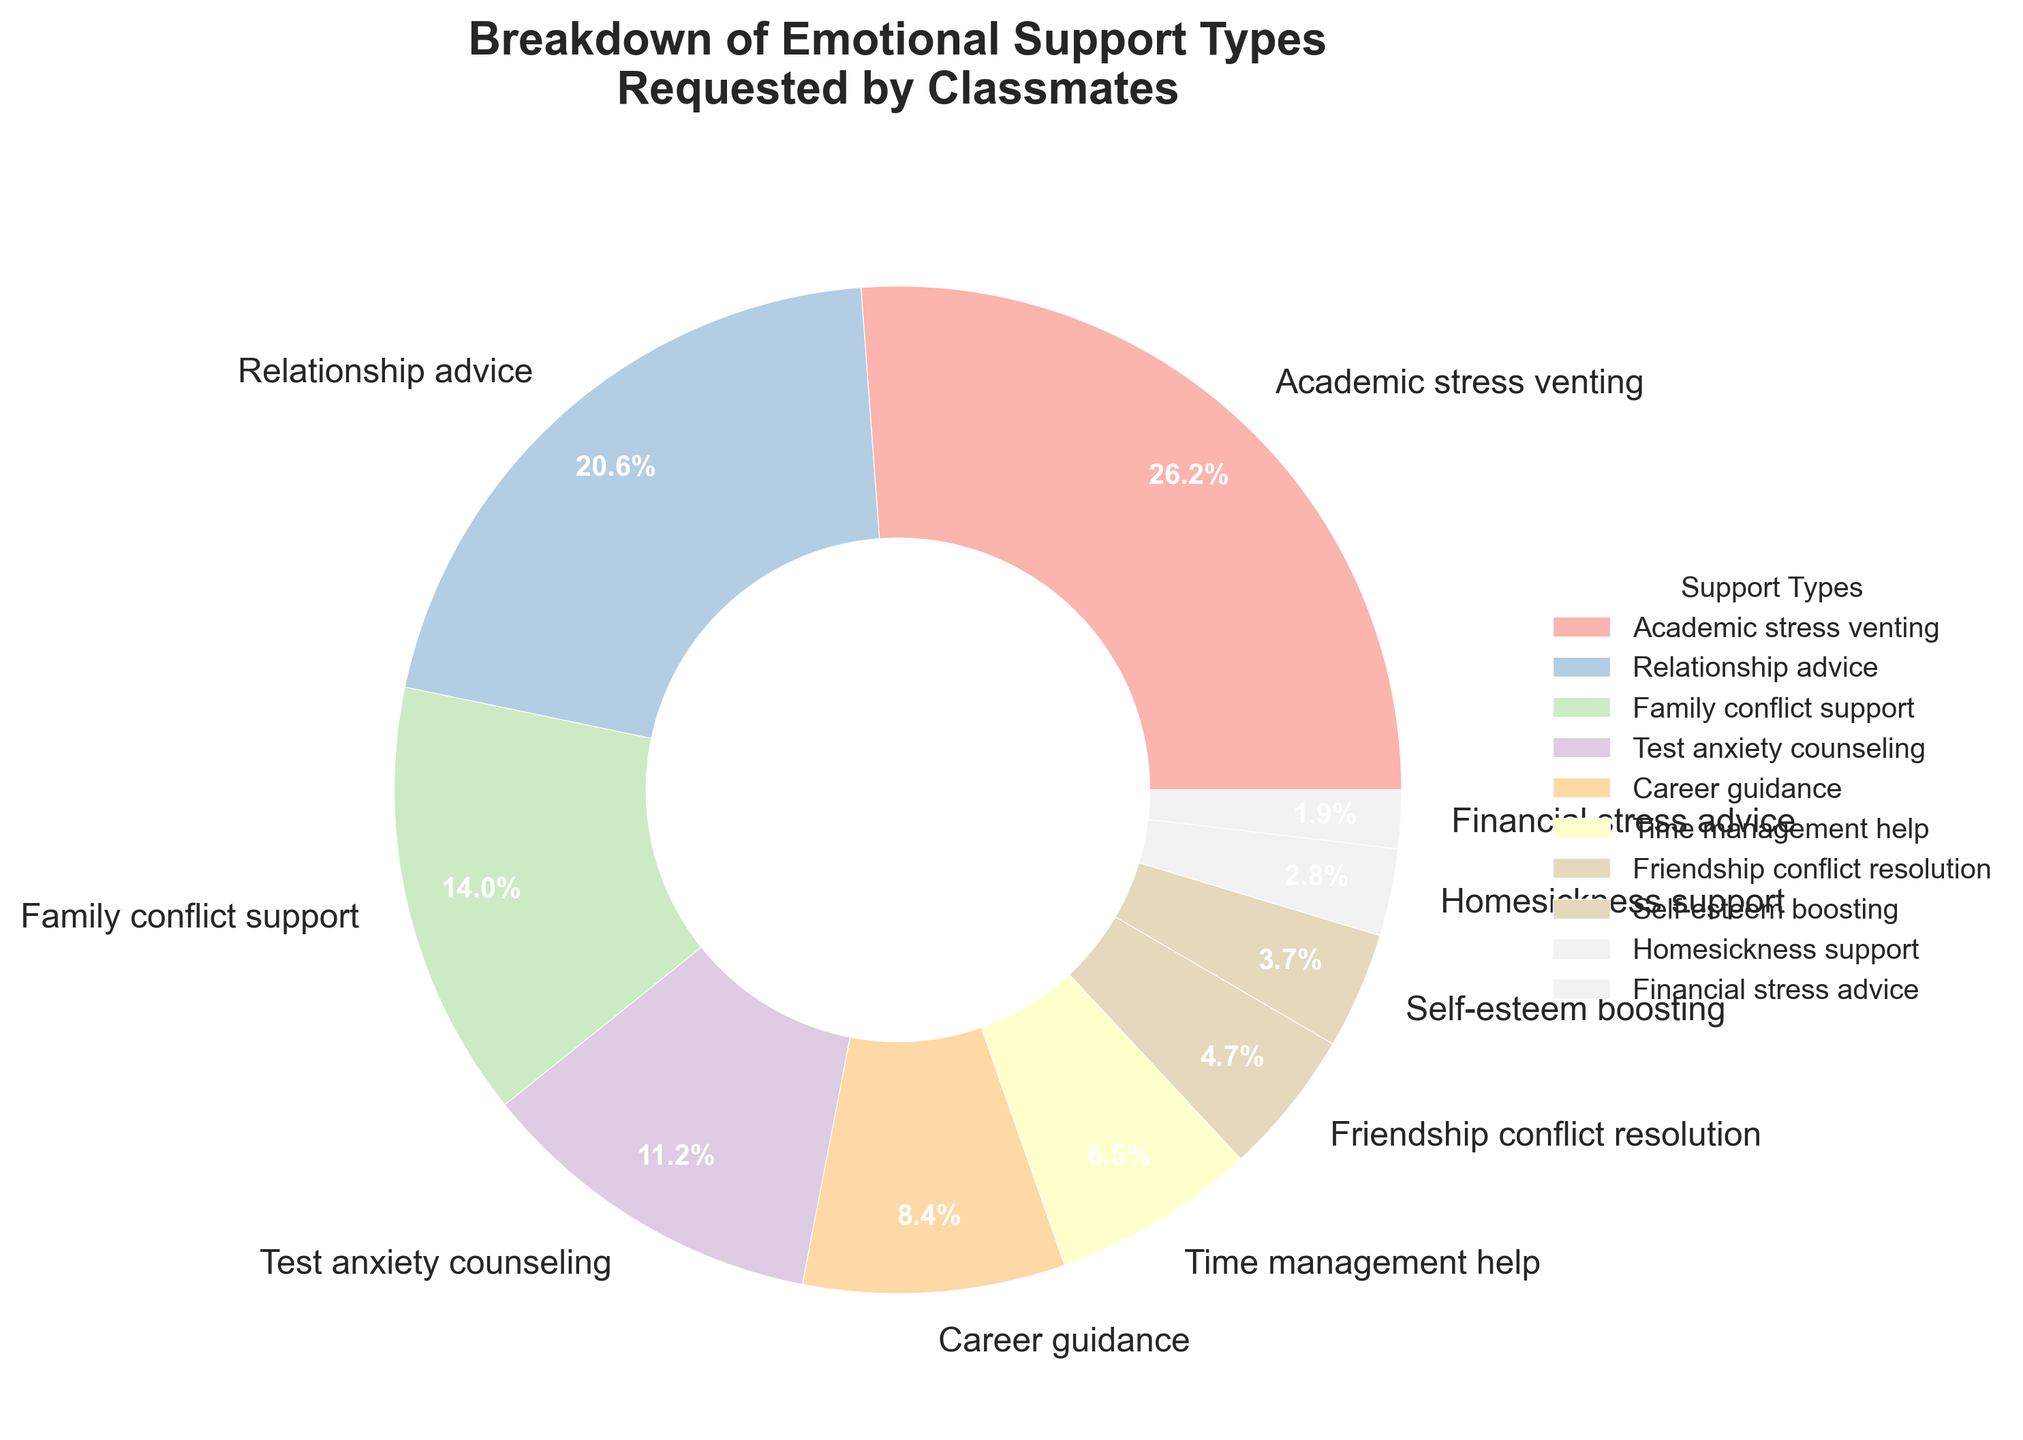What percentage of classmates requested help with family conflicts? Refer to the 'Family conflict support' segment of the pie chart, which lists its percentage directly.
Answer: 15% Which emotional support type has the smallest percentage of requests? Look at the segment with the smallest percentage and its corresponding label on the pie chart.
Answer: Financial stress advice What is the combined percentage for Career guidance and Time management help? Find the segments for 'Career guidance' (9%) and 'Time management help' (7%) and sum their percentages: 9% + 7%
Answer: 16% How many types of emotional support have a percentage lower than 10%? Count the segments that each represent less than 10%. These are Career guidance (9%), Time management help (7%), Friendship conflict resolution (5%), Self-esteem boosting (4%), Homesickness support (3%), and Financial stress advice (2%).
Answer: 6 Is the percentage for Academic stress venting greater than the sum of Family conflict support and Test anxiety counseling? Compare the percentage for 'Academic stress venting' (28%) with the combined percentages of 'Family conflict support' (15%) and 'Test anxiety counseling' (12%). Sum: 15% + 12% = 27%. Since 28% > 27%, it is indeed greater.
Answer: Yes Which type of emotional support is requested more frequently: Relationship advice or Academic stress venting? Compare their percentages directly as shown in the pie chart. Relationship advice is 22%, and Academic stress venting is 28%.
Answer: Academic stress venting What portion of the pie chart is represented by Test anxiety counseling, and what is its visual appearance? Look at the 'Test anxiety counseling' segment and its visual characteristics. It occupies 12% of the chart and is shown in a specific color from the pastel palette.
Answer: 12%, pastel color Calculate the average percentage of support types with percentages above 10%. Identify the relevant percentages: Academic stress venting (28%), Relationship advice (22%), Family conflict support (15%), and Test anxiety counseling (12%). Average: (28% + 22% + 15% + 12%) / 4 = 19.25%
Answer: 19.25% Are there more requested types of support above or below 10%? Count the support types above 10% (4 types) and below 10% (6 types). Compare the counts.
Answer: Below 10% 